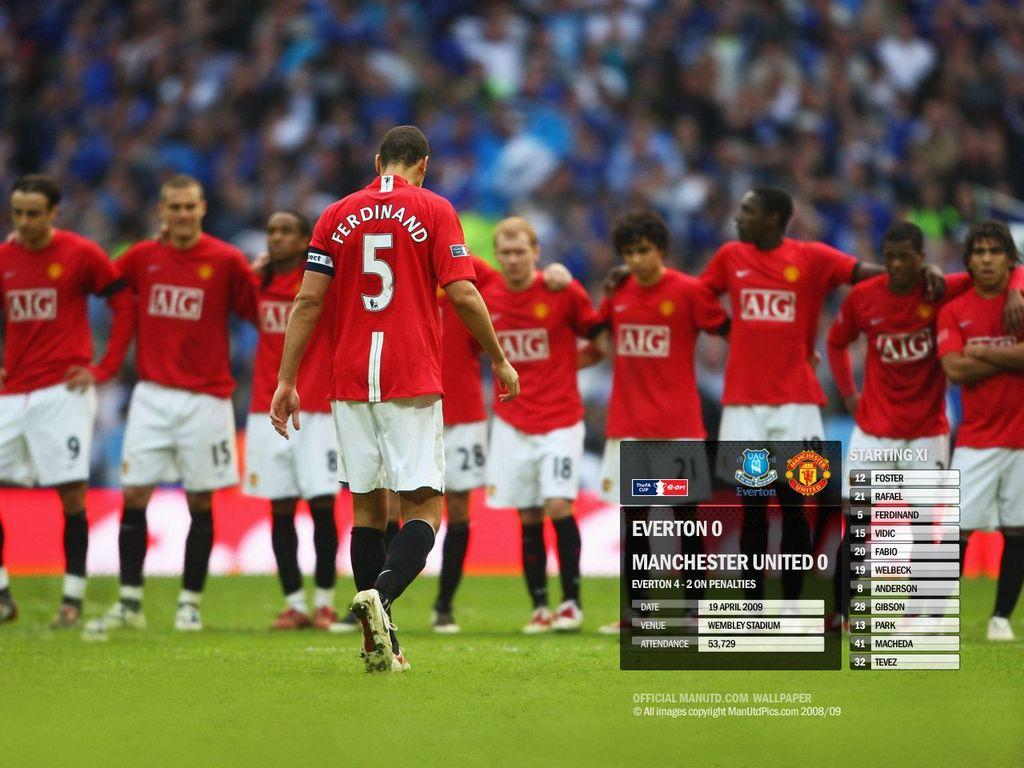<image>
Write a terse but informative summary of the picture. number 5 soccer player named 'ferdinand' on a field 